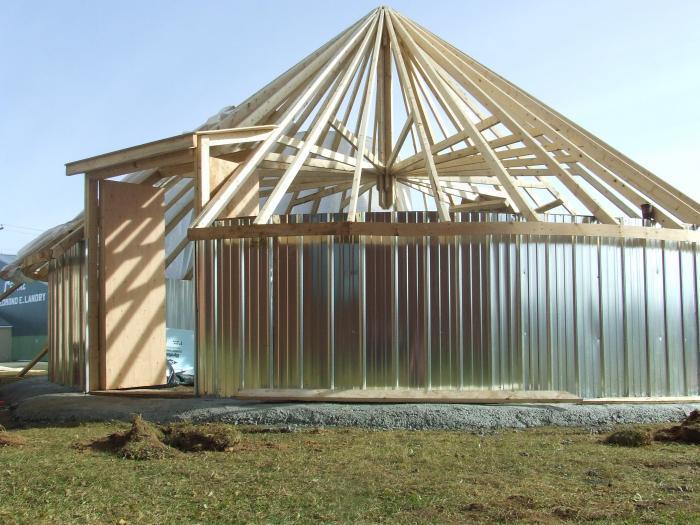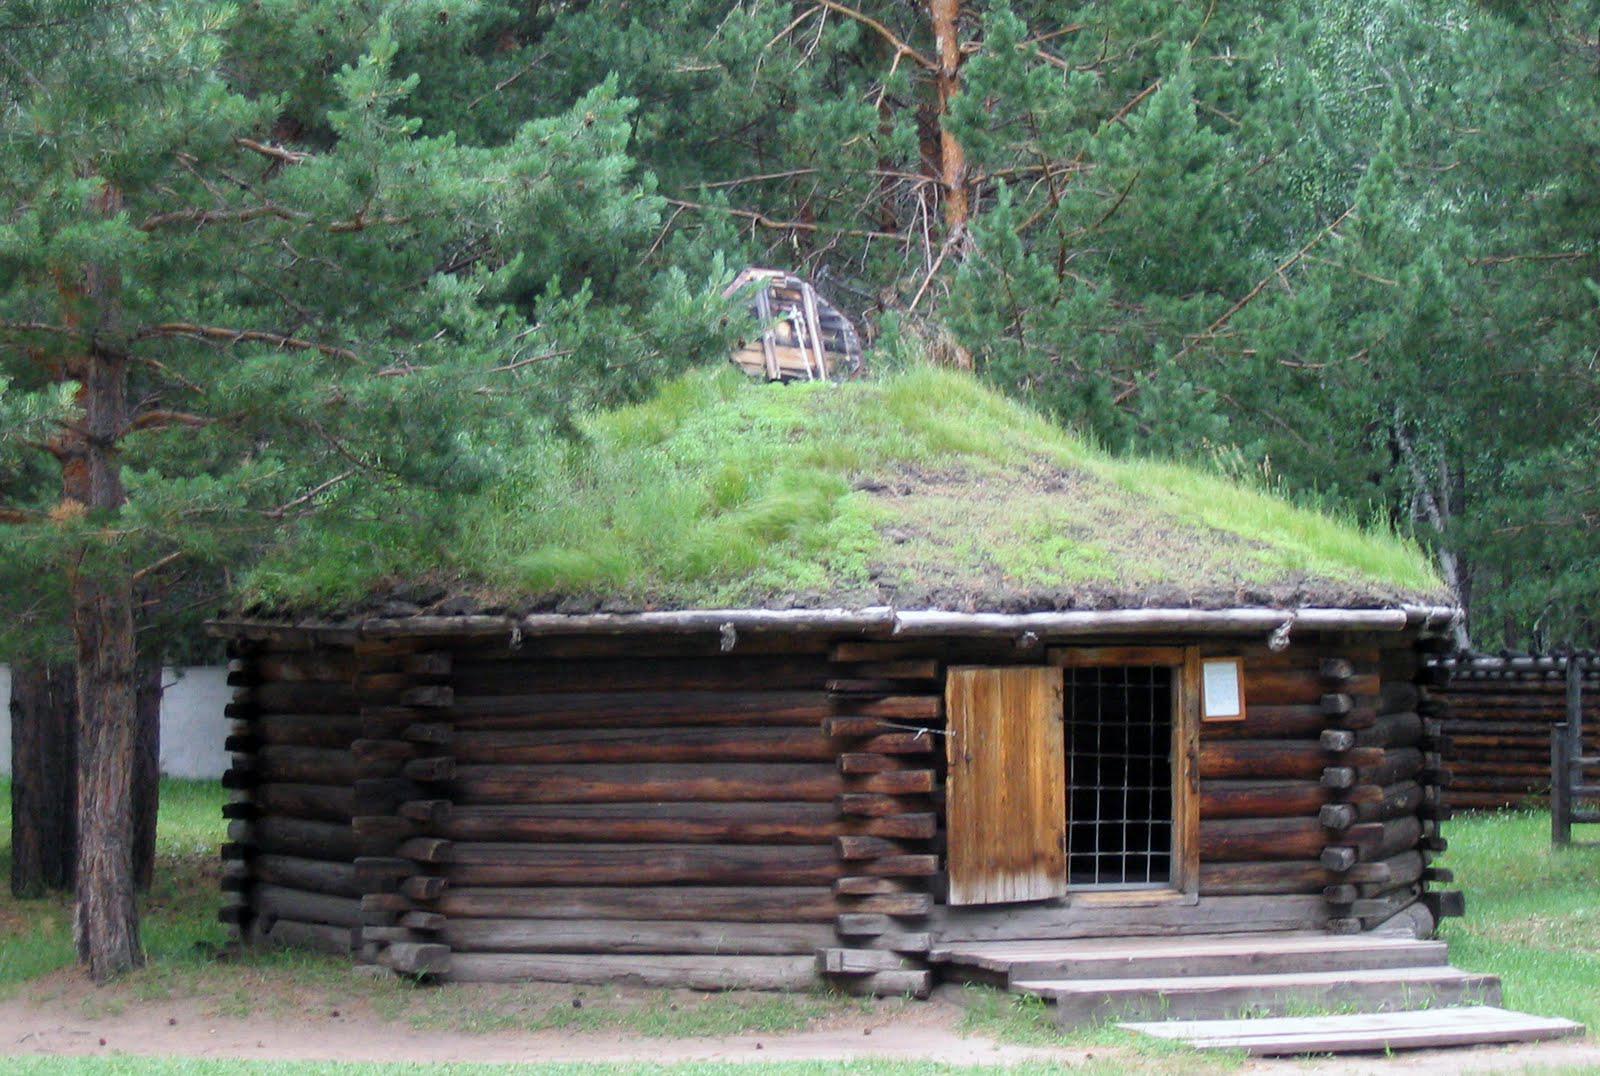The first image is the image on the left, the second image is the image on the right. For the images displayed, is the sentence "At least one image shows the exterior of a round yurt-type structure that is not fully enclosed, showing its wooden framework." factually correct? Answer yes or no. Yes. The first image is the image on the left, the second image is the image on the right. For the images shown, is this caption "All images show the outside of a yurt." true? Answer yes or no. Yes. 